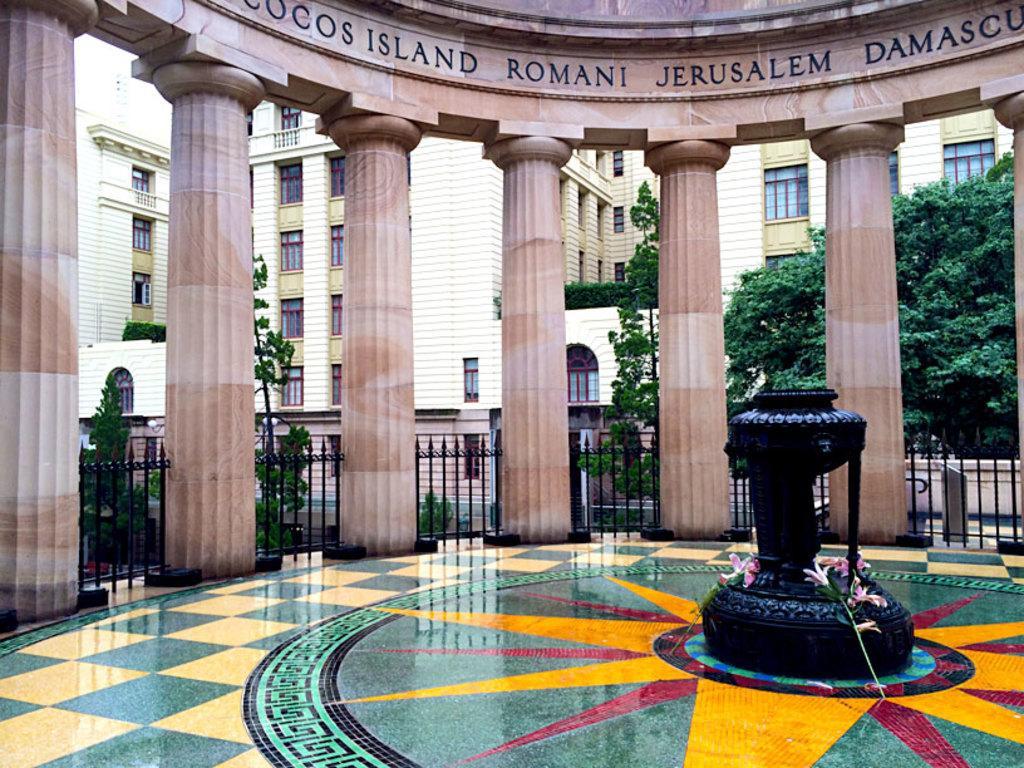Could you give a brief overview of what you see in this image? In this picture, we see a black color pole which looks like a fountain. Beside that, we see pink flowers. Behind that, we see pillars and railings. There are trees and buildings in the background. At the bottom of the picture, we see the floor, which is in green, yellow and red color. 